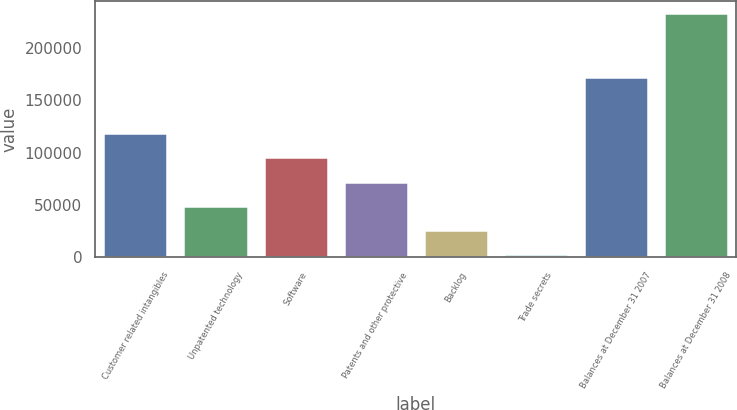Convert chart to OTSL. <chart><loc_0><loc_0><loc_500><loc_500><bar_chart><fcel>Customer related intangibles<fcel>Unpatented technology<fcel>Software<fcel>Patents and other protective<fcel>Backlog<fcel>Trade secrets<fcel>Balances at December 31 2007<fcel>Balances at December 31 2008<nl><fcel>118298<fcel>49385<fcel>95327<fcel>72356<fcel>26414<fcel>3443<fcel>171956<fcel>233153<nl></chart> 